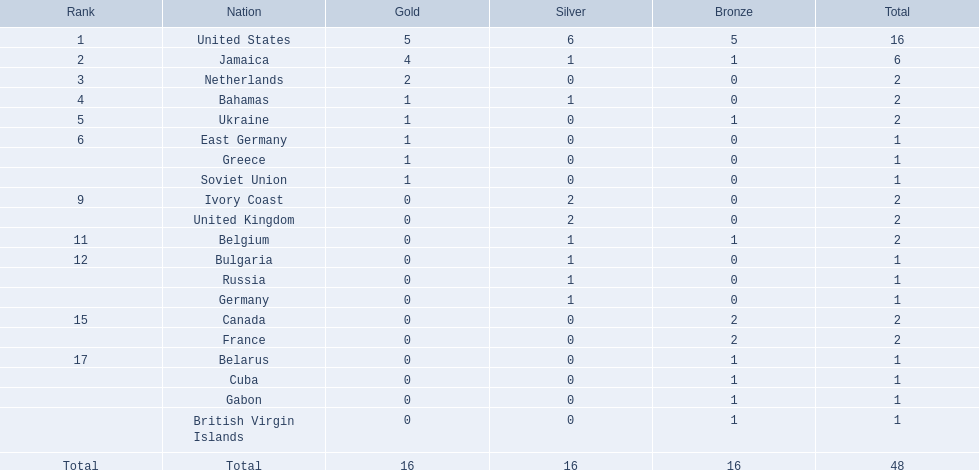What countries competed? United States, Jamaica, Netherlands, Bahamas, Ukraine, East Germany, Greece, Soviet Union, Ivory Coast, United Kingdom, Belgium, Bulgaria, Russia, Germany, Canada, France, Belarus, Cuba, Gabon, British Virgin Islands. Which countries won gold medals? United States, Jamaica, Netherlands, Bahamas, Ukraine, East Germany, Greece, Soviet Union. Which country had the second most medals? Jamaica. 